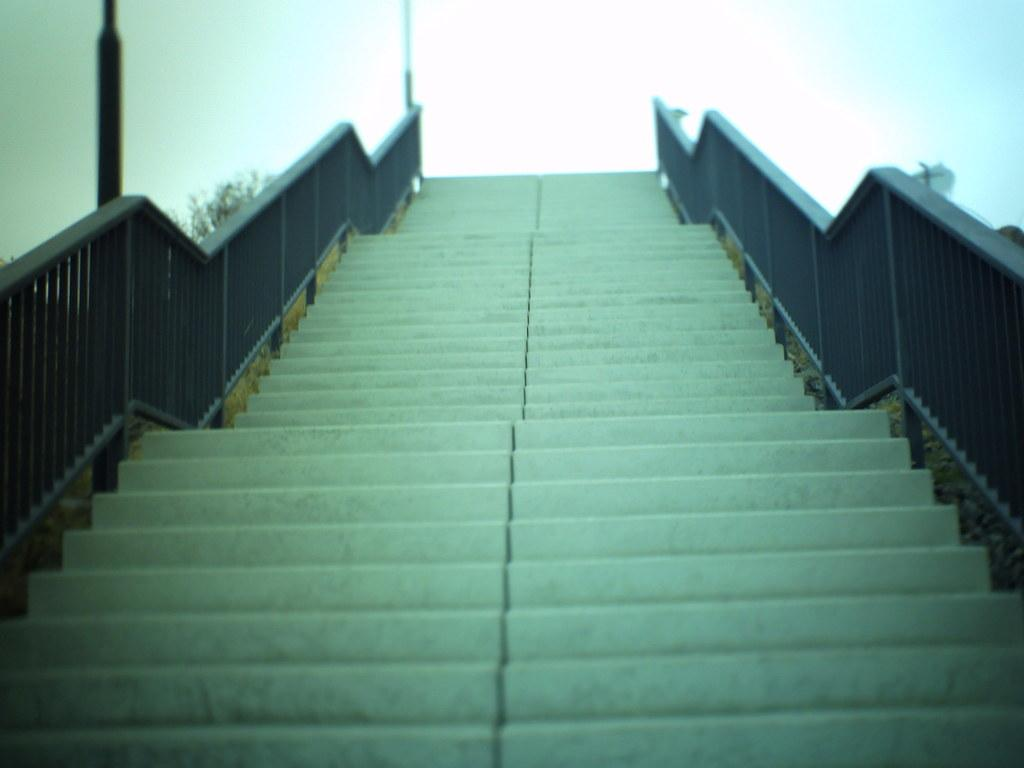What celestial objects can be seen in the image? There are stars visible in the image. What architectural feature is present in the image? There are iron grilles in the image. What type of plant is in the image? There is a tree in the image. What can be seen in the background of the image? The sky is visible in the background of the image. How many wrists are visible in the image? There are no wrists visible in the image. Are the hands visible in the image? There are no hands visible in the image. What type of metal is used in the iron grilles? The type of metal used in the iron grilles is not specified in the image. 